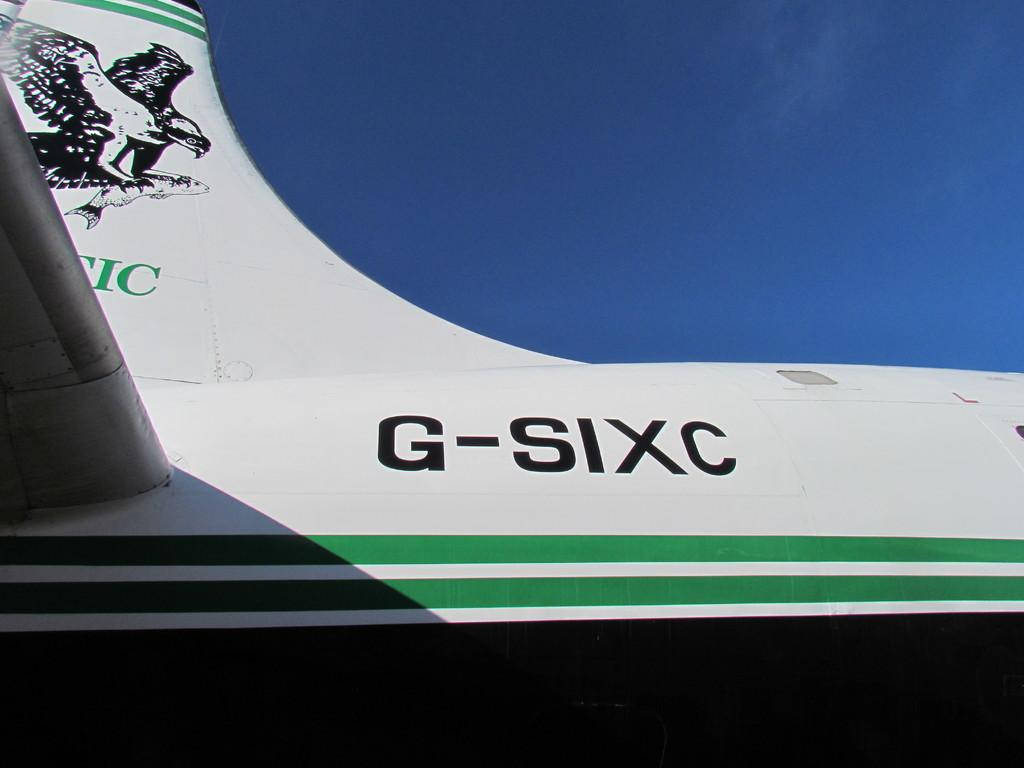<image>
Provide a brief description of the given image. the back of a plane that has the letters G-SIXC on it 